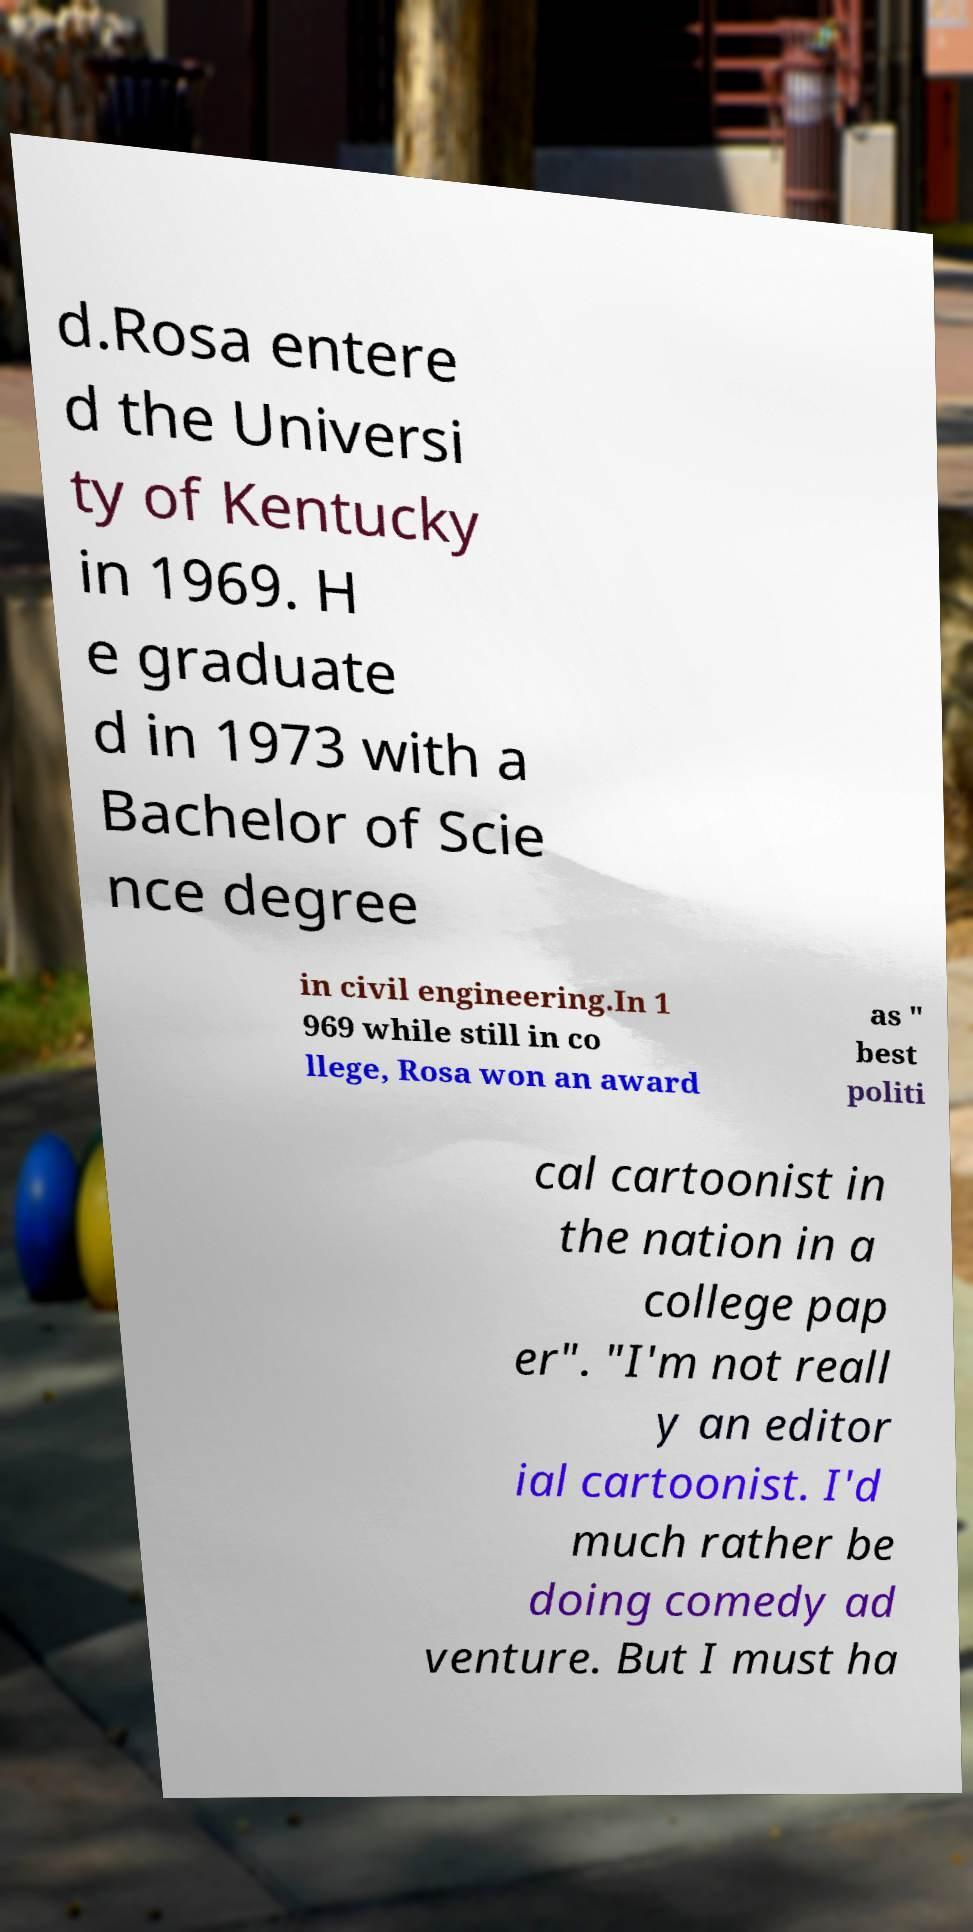Could you assist in decoding the text presented in this image and type it out clearly? d.Rosa entere d the Universi ty of Kentucky in 1969. H e graduate d in 1973 with a Bachelor of Scie nce degree in civil engineering.In 1 969 while still in co llege, Rosa won an award as " best politi cal cartoonist in the nation in a college pap er". "I'm not reall y an editor ial cartoonist. I'd much rather be doing comedy ad venture. But I must ha 